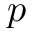<formula> <loc_0><loc_0><loc_500><loc_500>p</formula> 